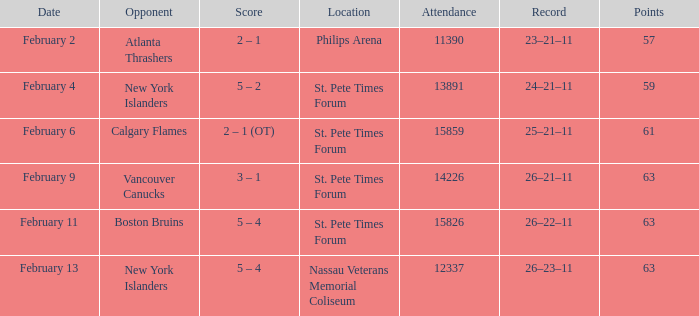What were the scores on february 9? 3 – 1. 